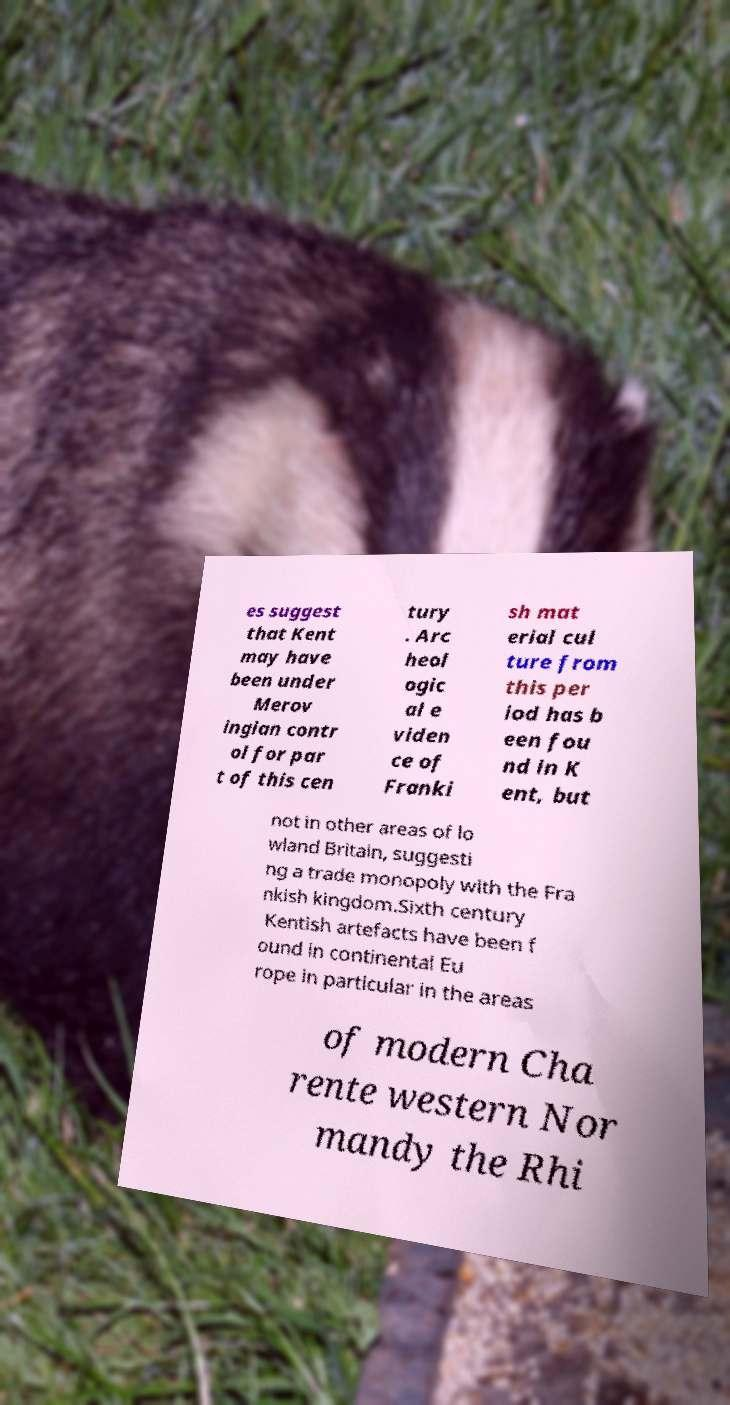Can you read and provide the text displayed in the image?This photo seems to have some interesting text. Can you extract and type it out for me? es suggest that Kent may have been under Merov ingian contr ol for par t of this cen tury . Arc heol ogic al e viden ce of Franki sh mat erial cul ture from this per iod has b een fou nd in K ent, but not in other areas of lo wland Britain, suggesti ng a trade monopoly with the Fra nkish kingdom.Sixth century Kentish artefacts have been f ound in continental Eu rope in particular in the areas of modern Cha rente western Nor mandy the Rhi 